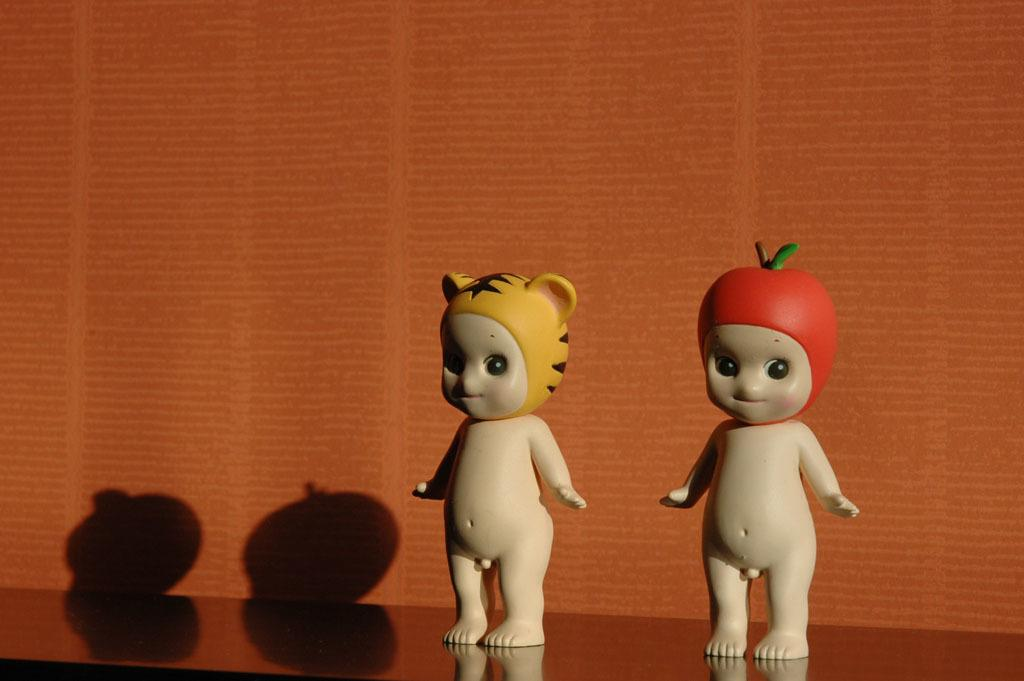What objects are in the foreground of the image? There are two toys in the foreground of the image. Where are the toys located? The toys are on a surface. What color is the background of the image? The background of the image is orange. What type of copper substance can be seen in the image? There is no copper substance present in the image. How does the wound appear in the image? There is no wound present in the image. 